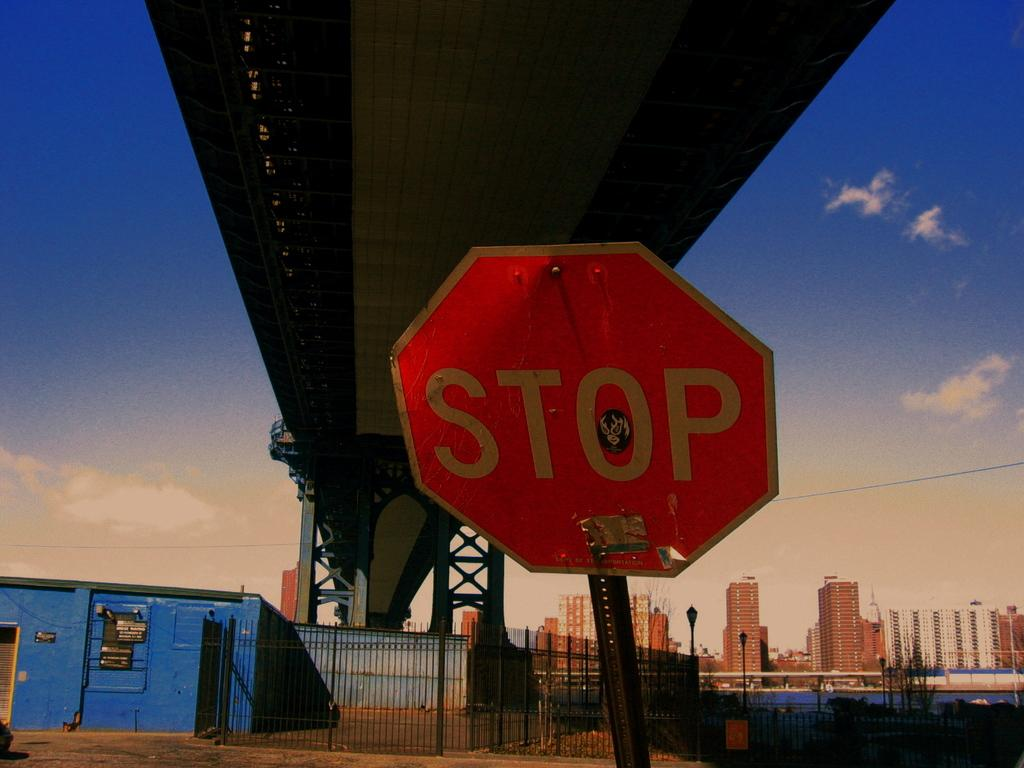<image>
Describe the image concisely. A red octagonal sign displays the word "stop" 